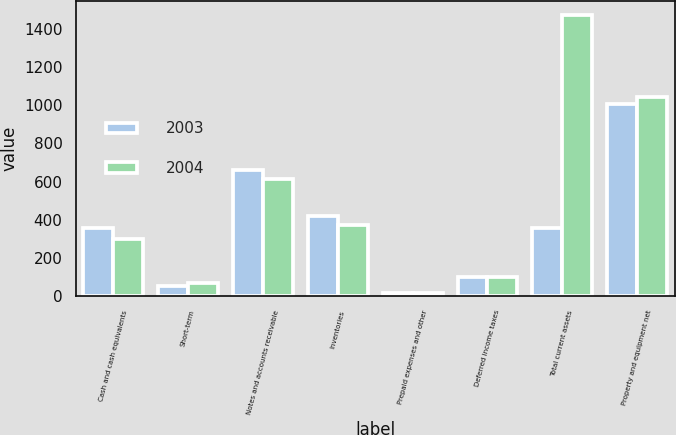Convert chart. <chart><loc_0><loc_0><loc_500><loc_500><stacked_bar_chart><ecel><fcel>Cash and cash equivalents<fcel>Short-term<fcel>Notes and accounts receivable<fcel>Inventories<fcel>Prepaid expenses and other<fcel>Deferred income taxes<fcel>Total current assets<fcel>Property and equipment net<nl><fcel>2003<fcel>358<fcel>54.1<fcel>662.5<fcel>417.9<fcel>17<fcel>101.7<fcel>358<fcel>1008.6<nl><fcel>2004<fcel>297.8<fcel>67.2<fcel>615.2<fcel>371.2<fcel>18.8<fcel>100.6<fcel>1470.8<fcel>1042.4<nl></chart> 